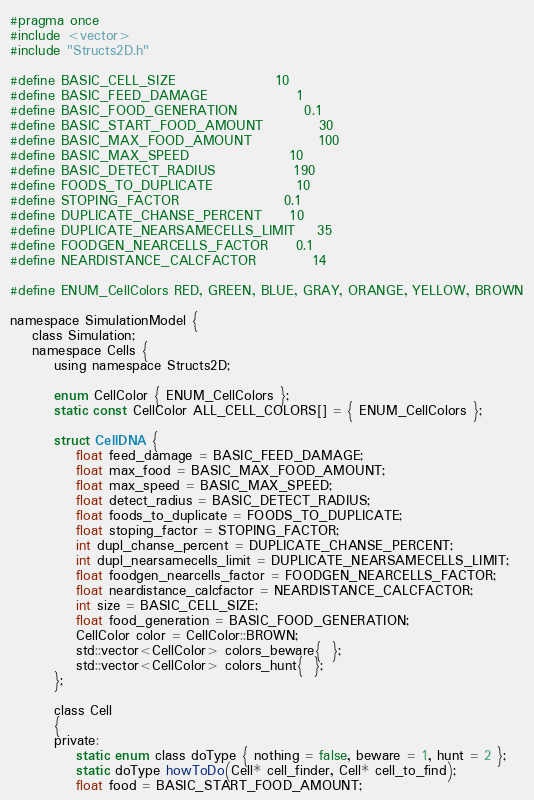Convert code to text. <code><loc_0><loc_0><loc_500><loc_500><_C_>#pragma once
#include <vector>
#include "Structs2D.h"

#define BASIC_CELL_SIZE					10
#define BASIC_FEED_DAMAGE				1
#define BASIC_FOOD_GENERATION			0.1
#define BASIC_START_FOOD_AMOUNT			30
#define BASIC_MAX_FOOD_AMOUNT			100
#define BASIC_MAX_SPEED					10
#define BASIC_DETECT_RADIUS				190
#define FOODS_TO_DUPLICATE				10
#define STOPING_FACTOR					0.1
#define DUPLICATE_CHANSE_PERCENT		10
#define DUPLICATE_NEARSAMECELLS_LIMIT	35
#define FOODGEN_NEARCELLS_FACTOR		0.1
#define NEARDISTANCE_CALCFACTOR			14

#define ENUM_CellColors RED, GREEN, BLUE, GRAY, ORANGE, YELLOW, BROWN

namespace SimulationModel {
	class Simulation;
	namespace Cells {
		using namespace Structs2D;

		enum CellColor { ENUM_CellColors };
		static const CellColor ALL_CELL_COLORS[] = { ENUM_CellColors };

		struct CellDNA {
			float feed_damage = BASIC_FEED_DAMAGE;
			float max_food = BASIC_MAX_FOOD_AMOUNT;
			float max_speed = BASIC_MAX_SPEED;
			float detect_radius = BASIC_DETECT_RADIUS;
			float foods_to_duplicate = FOODS_TO_DUPLICATE;
			float stoping_factor = STOPING_FACTOR;
			int dupl_chanse_percent = DUPLICATE_CHANSE_PERCENT;
			int dupl_nearsamecells_limit = DUPLICATE_NEARSAMECELLS_LIMIT;
			float foodgen_nearcells_factor = FOODGEN_NEARCELLS_FACTOR;
			float neardistance_calcfactor = NEARDISTANCE_CALCFACTOR;
			int size = BASIC_CELL_SIZE;
			float food_generation = BASIC_FOOD_GENERATION;
			CellColor color = CellColor::BROWN;
			std::vector<CellColor> colors_beware{  };
			std::vector<CellColor> colors_hunt{  };
		};

		class Cell
		{
		private:
			static enum class doType { nothing = false, beware = 1, hunt = 2 };
			static doType howToDo(Cell* cell_finder, Cell* cell_to_find);
			float food = BASIC_START_FOOD_AMOUNT;</code> 